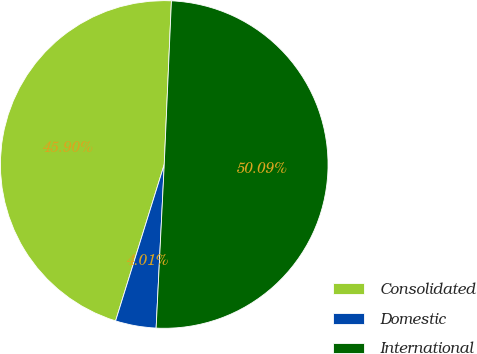Convert chart to OTSL. <chart><loc_0><loc_0><loc_500><loc_500><pie_chart><fcel>Consolidated<fcel>Domestic<fcel>International<nl><fcel>45.9%<fcel>4.01%<fcel>50.09%<nl></chart> 